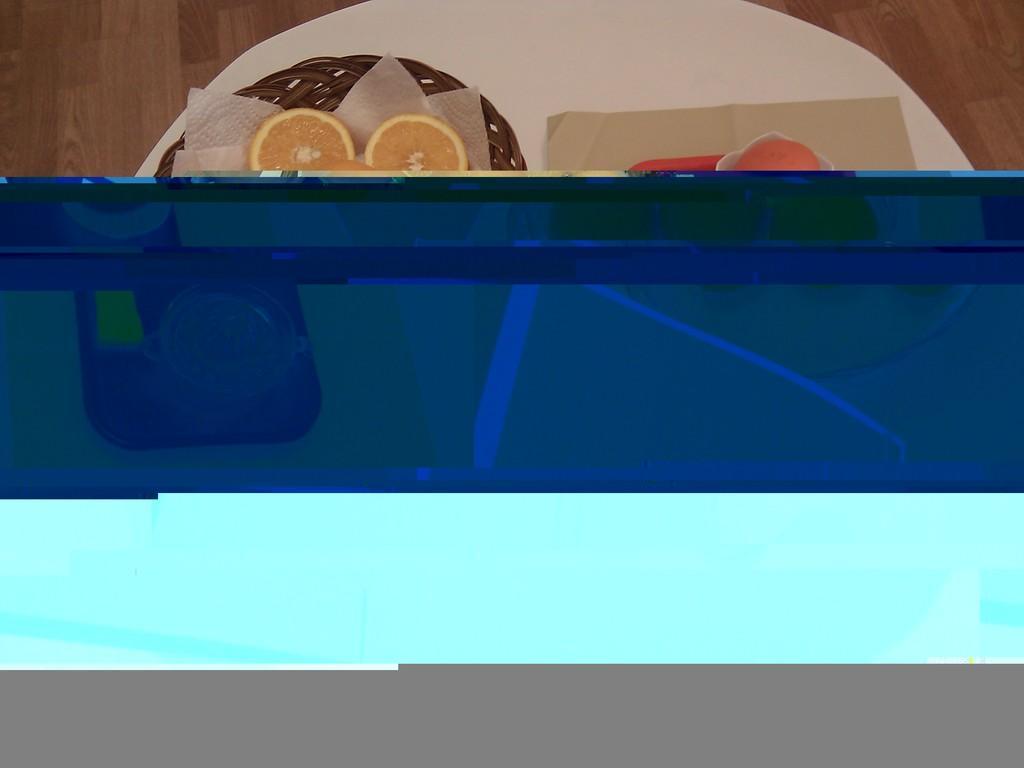Describe this image in one or two sentences. In the center of the image there is a glass object, which is in a blue color. And we can see two different colors at the bottom of the image. At the top of the image there is a wooden floor. On the wooden floor, we can see one table. On the table, we can see one wooden object, tissue papers, orange slices, one fruit and a few other objects. 